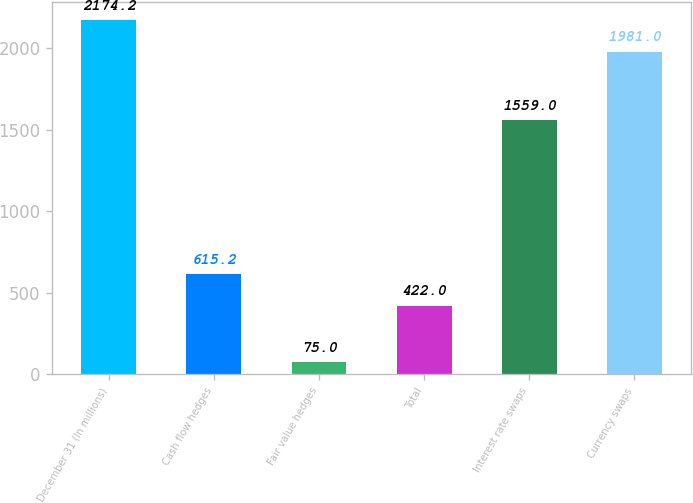Convert chart. <chart><loc_0><loc_0><loc_500><loc_500><bar_chart><fcel>December 31 (In millions)<fcel>Cash flow hedges<fcel>Fair value hedges<fcel>Total<fcel>Interest rate swaps<fcel>Currency swaps<nl><fcel>2174.2<fcel>615.2<fcel>75<fcel>422<fcel>1559<fcel>1981<nl></chart> 